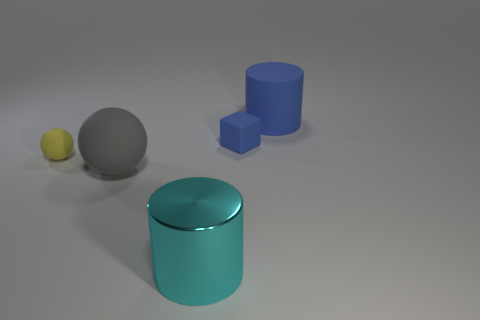Subtract all blue cylinders. How many cylinders are left? 1 Subtract all balls. How many objects are left? 3 Subtract 1 cylinders. How many cylinders are left? 1 Add 3 small yellow rubber spheres. How many objects exist? 8 Add 3 big green objects. How many big green objects exist? 3 Subtract 0 cyan blocks. How many objects are left? 5 Subtract all yellow cylinders. Subtract all gray balls. How many cylinders are left? 2 Subtract all tiny purple metal cylinders. Subtract all large cyan objects. How many objects are left? 4 Add 5 small blocks. How many small blocks are left? 6 